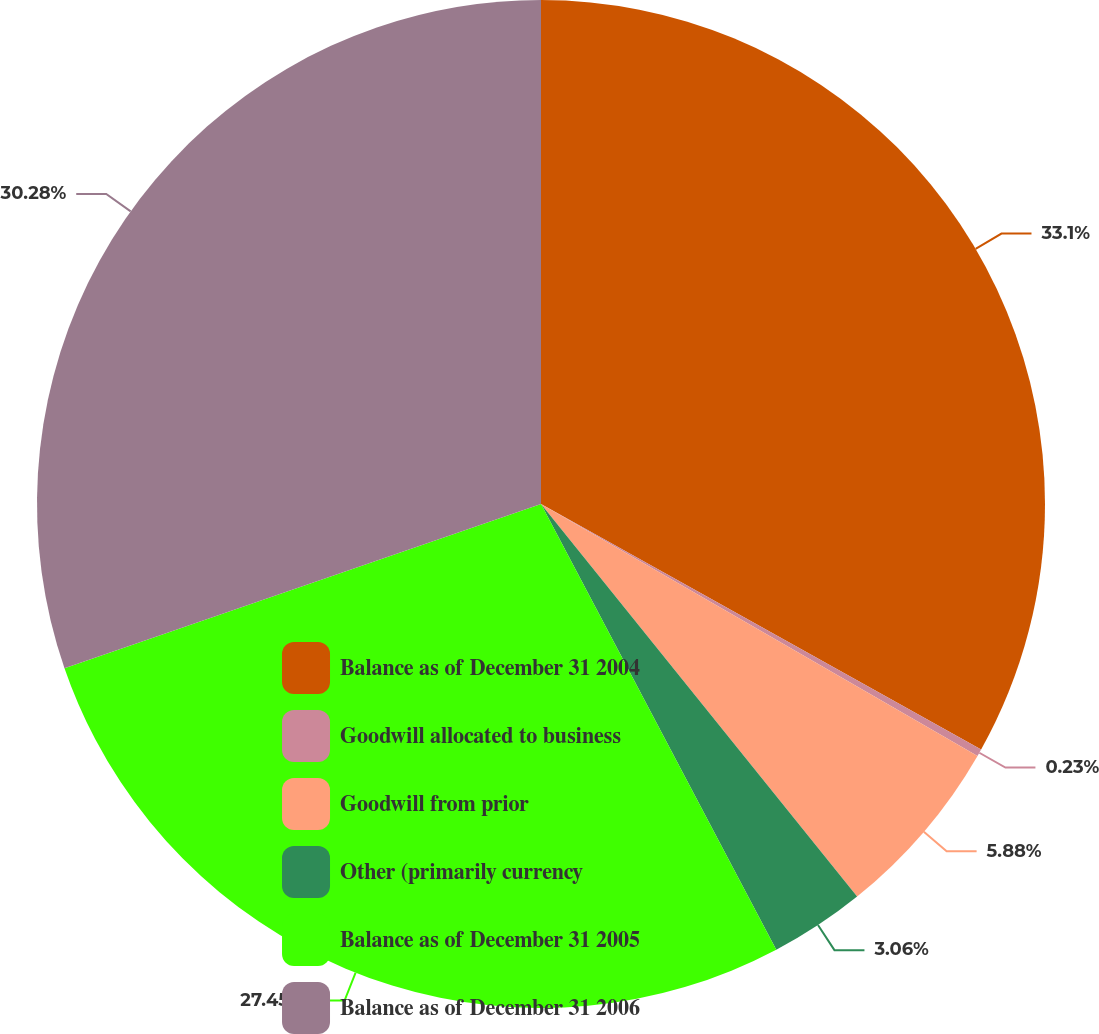Convert chart. <chart><loc_0><loc_0><loc_500><loc_500><pie_chart><fcel>Balance as of December 31 2004<fcel>Goodwill allocated to business<fcel>Goodwill from prior<fcel>Other (primarily currency<fcel>Balance as of December 31 2005<fcel>Balance as of December 31 2006<nl><fcel>33.1%<fcel>0.23%<fcel>5.88%<fcel>3.06%<fcel>27.45%<fcel>30.28%<nl></chart> 